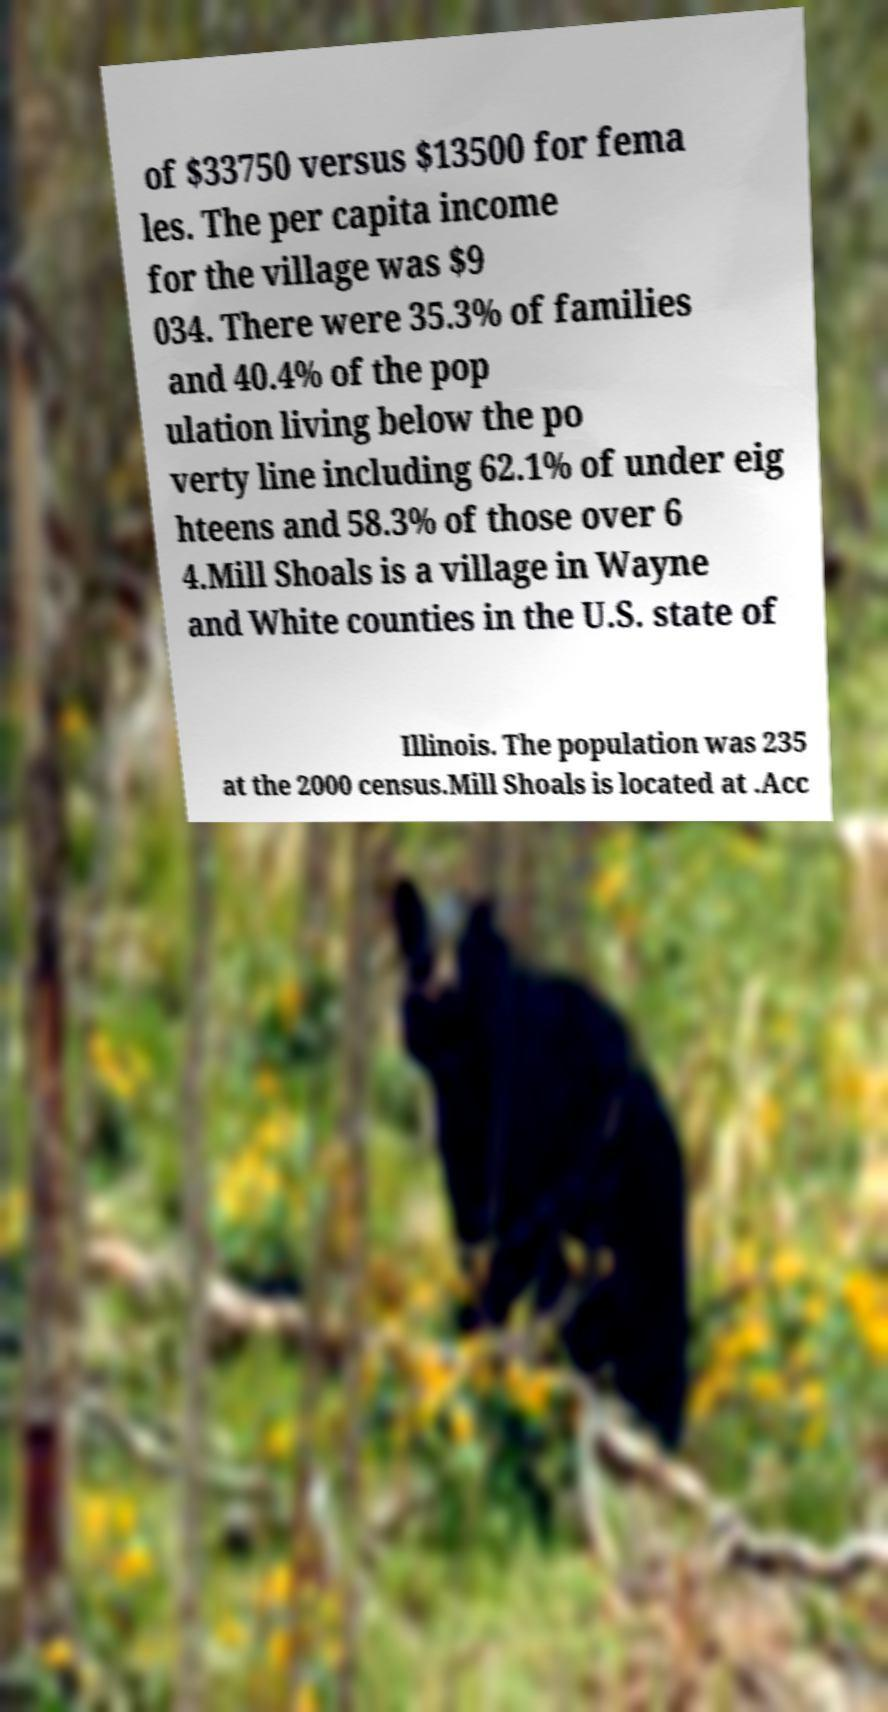Please read and relay the text visible in this image. What does it say? of $33750 versus $13500 for fema les. The per capita income for the village was $9 034. There were 35.3% of families and 40.4% of the pop ulation living below the po verty line including 62.1% of under eig hteens and 58.3% of those over 6 4.Mill Shoals is a village in Wayne and White counties in the U.S. state of Illinois. The population was 235 at the 2000 census.Mill Shoals is located at .Acc 